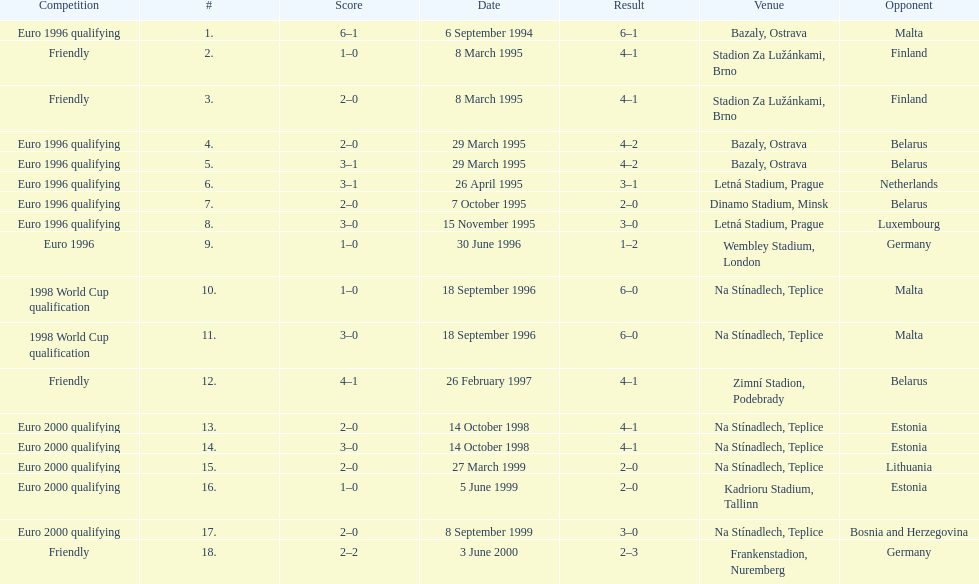How many total games took place in 1999? 3. 